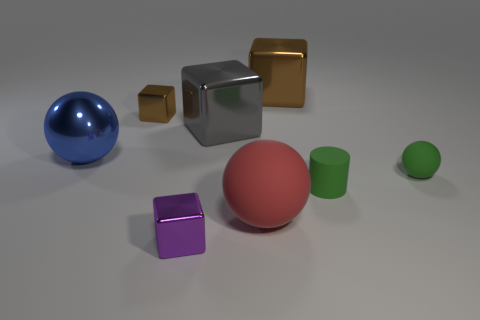Subtract all red balls. How many balls are left? 2 Subtract all gray cubes. How many cubes are left? 3 Add 2 yellow rubber balls. How many objects exist? 10 Subtract 0 cyan cylinders. How many objects are left? 8 Subtract all cylinders. How many objects are left? 7 Subtract all red spheres. Subtract all brown cubes. How many spheres are left? 2 Subtract all cyan cubes. How many blue spheres are left? 1 Subtract all big gray metal objects. Subtract all matte spheres. How many objects are left? 5 Add 6 small green rubber spheres. How many small green rubber spheres are left? 7 Add 8 gray things. How many gray things exist? 9 